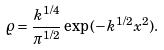<formula> <loc_0><loc_0><loc_500><loc_500>\varrho = \frac { k ^ { 1 / 4 } } { \pi ^ { 1 / 2 } } \exp { ( - k ^ { 1 / 2 } x ^ { 2 } ) } .</formula> 